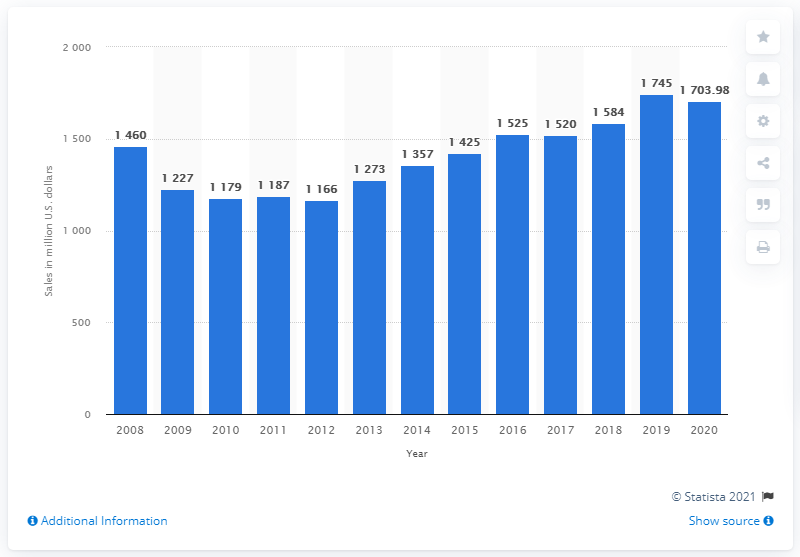Indicate a few pertinent items in this graphic. La-Z-Boy's global sales in 2020 were 1703.98. 